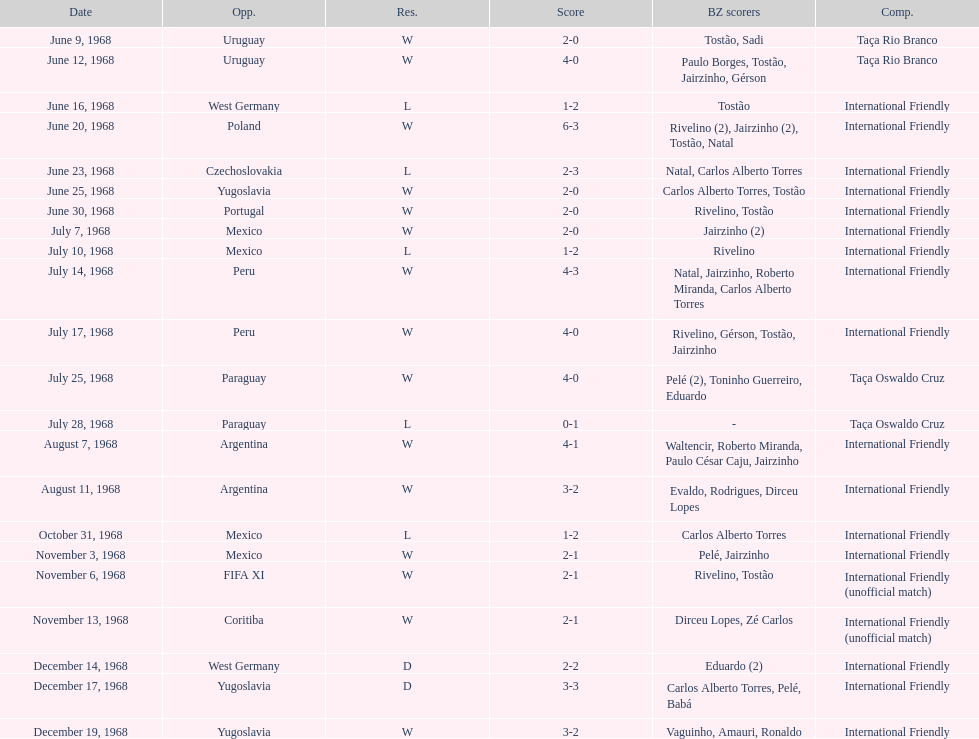What is the top score ever scored by the brazil national team? 6. 